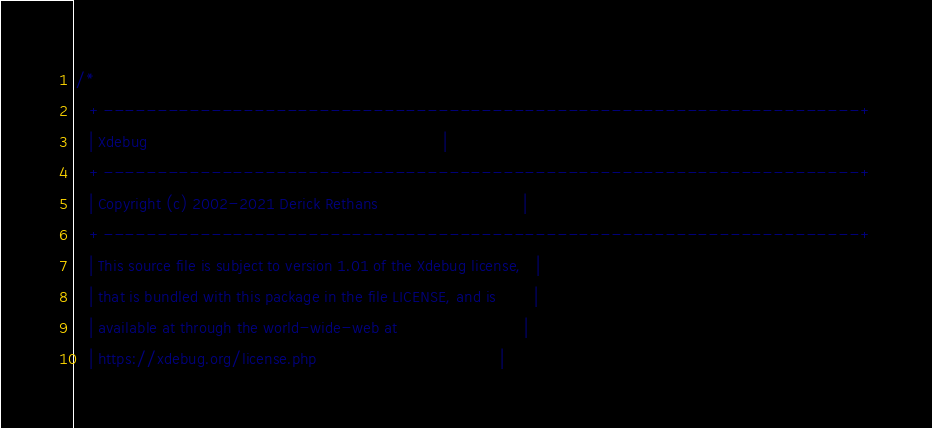Convert code to text. <code><loc_0><loc_0><loc_500><loc_500><_C_>/*
   +----------------------------------------------------------------------+
   | Xdebug                                                               |
   +----------------------------------------------------------------------+
   | Copyright (c) 2002-2021 Derick Rethans                               |
   +----------------------------------------------------------------------+
   | This source file is subject to version 1.01 of the Xdebug license,   |
   | that is bundled with this package in the file LICENSE, and is        |
   | available at through the world-wide-web at                           |
   | https://xdebug.org/license.php                                       |</code> 